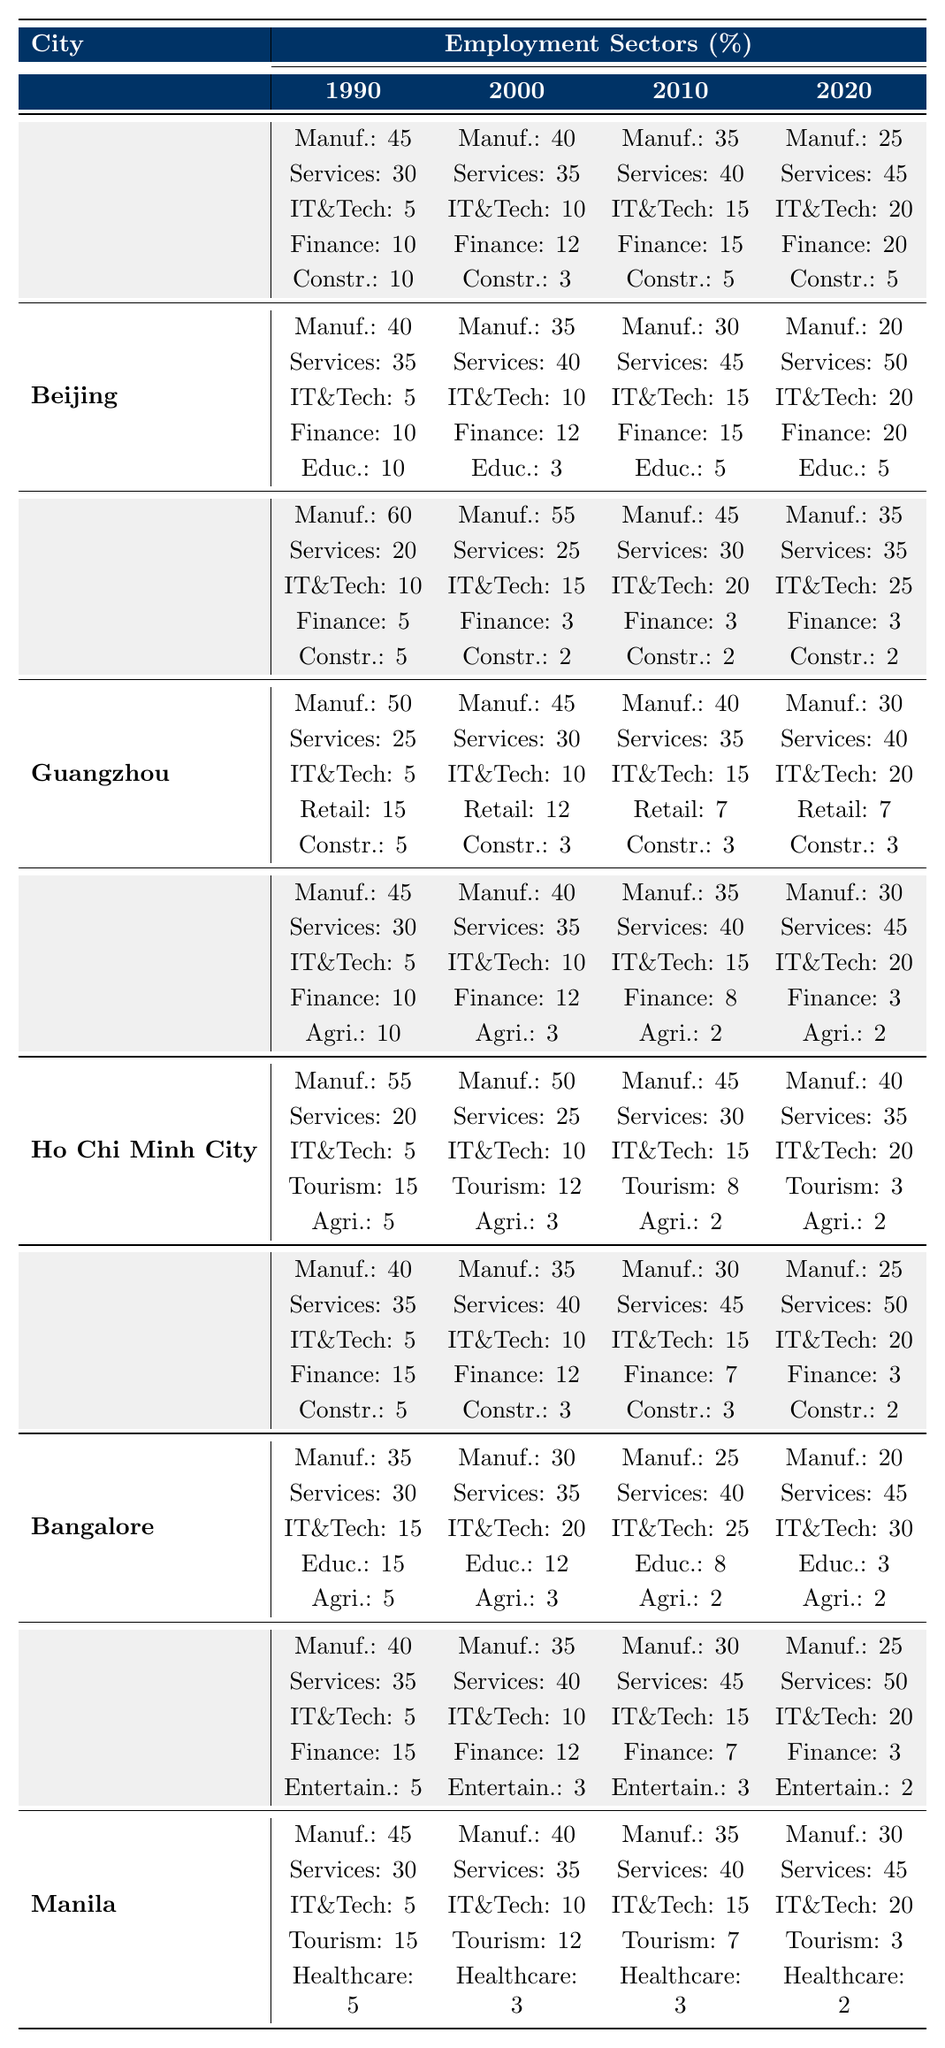What percentage of employment in Shanghai was in the IT and Technology sector in 2020? In 2020, the table indicates that the percentage of employment in the IT and Technology sector in Shanghai was 20%.
Answer: 20% Which city had the highest percentage of employment in Services in 2010? According to the table, in 2010, Beijing had the highest percentage of employment in Services, which was 45%.
Answer: Beijing What sector showed a decline in employment from 1990 to 2020 in Shenzhen? The Manufacturing sector in Shenzhen declined from 60% in 1990 to 35% in 2020.
Answer: Manufacturing Which city's employment in Finance decreased the most from 1990 to 2020? To determine the largest decrease in Finance, we look at the values: Shanghai (10 to 20), Beijing (10 to 20), Chengdu (10 to 3), Shenzhen (5 to 3), Jakarta (15 to 3), Bangalore (15 to 3), Mumbai (15 to 3), Manila (5 to 2). The highest decrease was in Chengdu, where Finance dropped from 10% to 3%.
Answer: Chengdu What was the overall trend for the Manufacturing sector across the cities from 1990 to 2020? Observing the table, the Manufacturing sector consistently decreased in all cities from 1990 to 2020, indicating a general decline in this employment sector.
Answer: Decrease Calculate the average percentage of employment in IT and Technology across all cities in 2020. The percentages for 2020 are: Shanghai (20), Beijing (20), Shenzhen (25), Guangzhou (20), Chengdu (20), Ho Chi Minh City (20), Jakarta (20), Bangalore (30), Mumbai (20), Manila (20). Summing these gives 20 + 20 + 25 + 20 + 20 + 20 + 20 + 30 + 20 + 20 = 215. There are 10 data points, so the average is 215/10 = 21.5%.
Answer: 21.5% Is it true that all cities had a percentage higher than 30% in Services by 2020? By checking the 2020 values for Services: Shanghai (45), Beijing (50), Shenzhen (35), Guangzhou (40), Chengdu (45), Ho Chi Minh City (35), Jakarta (50), Bangalore (45), Mumbai (50), Manila (45), it shows that all cities indeed had more than 30%. Therefore, the statement is true.
Answer: Yes Which employment sector has shown the least fluctuation in its percentage across the four years for Beijing? Looking at Beijing's data across 1990, 2000, 2010, and 2020 for all sectors, the Education sector had percentages of 10, 3, 5, and 5, which showcase the least fluctuation.
Answer: Education In how many cities did the percentage of Manufacturing drop below 30% by 2020? The cities where Manufacturing fell below 30% in 2020 are Shanghai, Guangzhou, Shenzhen, Jakarta, Bangalore, and Mumbai. Counting these gives us 6 cities.
Answer: 6 What was the change in percentage for Healthcare in Manila from 1990 to 2020? The percentage of Healthcare in Manila decreased from 5% in 1990 to 2% in 2020, marking a change of -3%.
Answer: -3% 